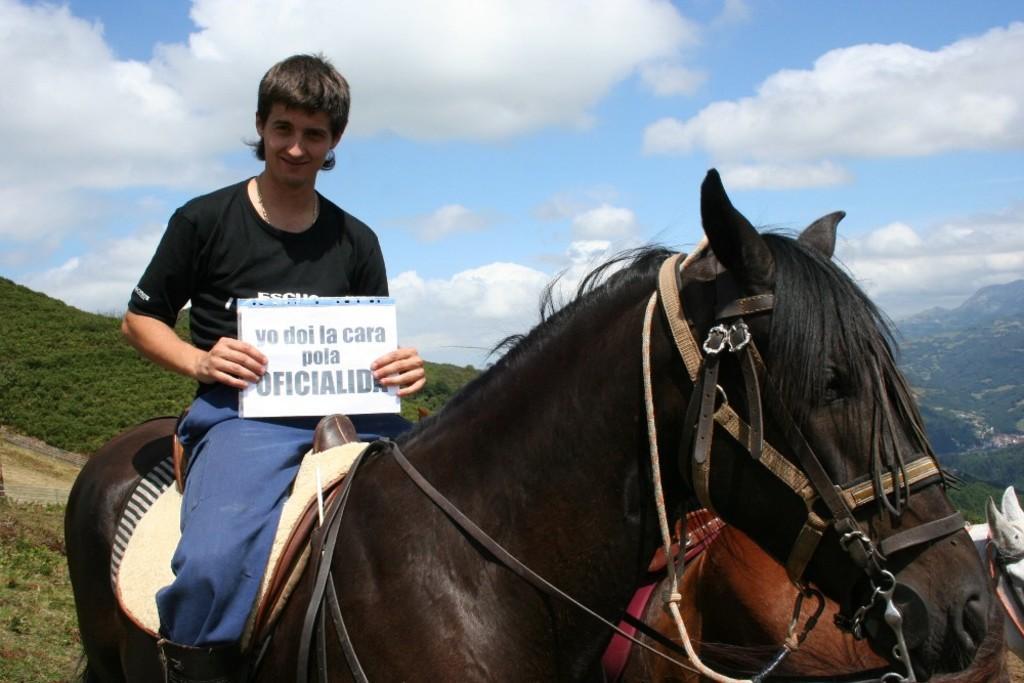How would you summarize this image in a sentence or two? Here in this picture we can see a man is sitting on a horse and we can see he is smiling and holding a paper in his hands and we can see the ground is fully covered with grass and beside that horse we can see another horse also present and in the far we can see mountains present and we can see clouds in the sky. 